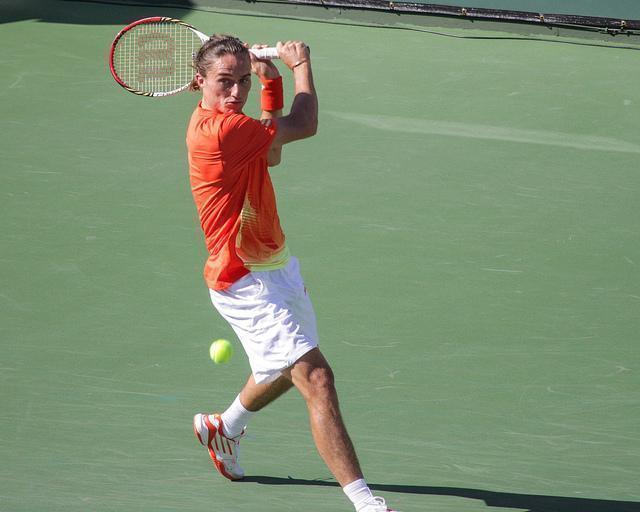Why is the man holding the racket back?
Select the accurate answer and provide explanation: 'Answer: answer
Rationale: rationale.'
Options: To itch, to swing, to drop, to block. Answer: to swing.
Rationale: He is ready to swing the racquet at the ball. 